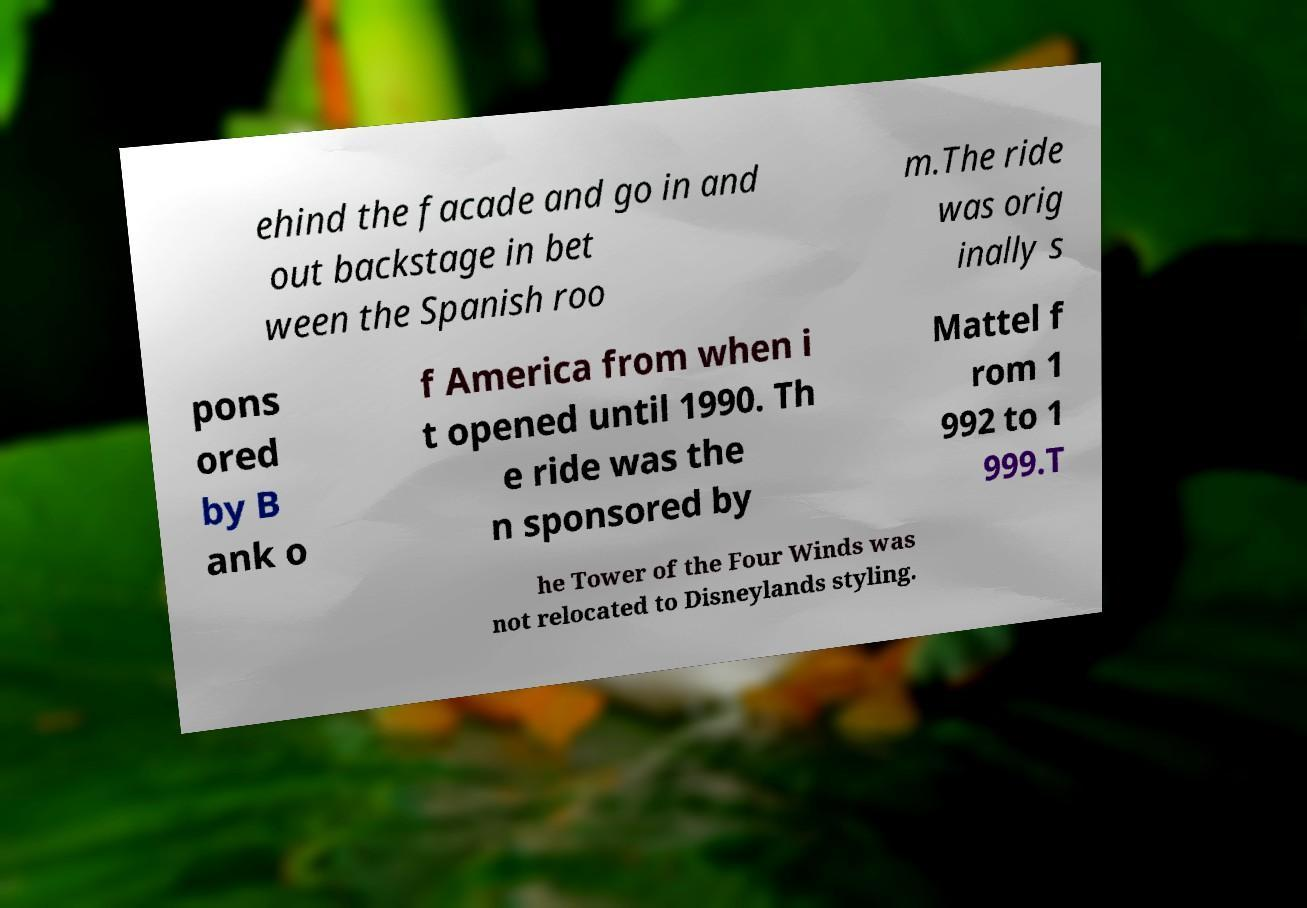Can you accurately transcribe the text from the provided image for me? ehind the facade and go in and out backstage in bet ween the Spanish roo m.The ride was orig inally s pons ored by B ank o f America from when i t opened until 1990. Th e ride was the n sponsored by Mattel f rom 1 992 to 1 999.T he Tower of the Four Winds was not relocated to Disneylands styling. 